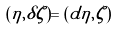<formula> <loc_0><loc_0><loc_500><loc_500>( \eta , \delta \zeta ) = ( d \eta , \zeta )</formula> 